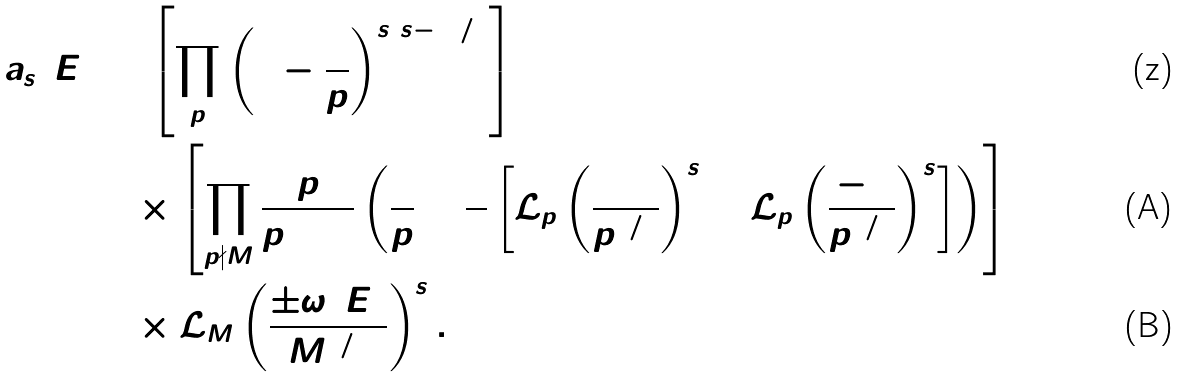Convert formula to latex. <formula><loc_0><loc_0><loc_500><loc_500>a _ { s } ( E ) & = \left [ \prod _ { p } \left ( 1 - \frac { 1 } { p } \right ) ^ { s ( s - 1 ) / 2 } \right ] \\ & \quad \times \left [ \prod _ { p \nmid M } \frac { p } { p + 1 } \left ( \frac { 1 } { p } + \frac { 1 } { 2 } \left [ \mathcal { L } _ { p } \left ( \frac { 1 } { p ^ { 1 / 2 } } \right ) ^ { s } + \mathcal { L } _ { p } \left ( \frac { - 1 } { p ^ { 1 / 2 } } \right ) ^ { s } \right ] \right ) \right ] \\ & \quad \times \mathcal { L } _ { M } \left ( \frac { \pm \omega ( E ) } { M ^ { 1 / 2 } } \right ) ^ { s } .</formula> 